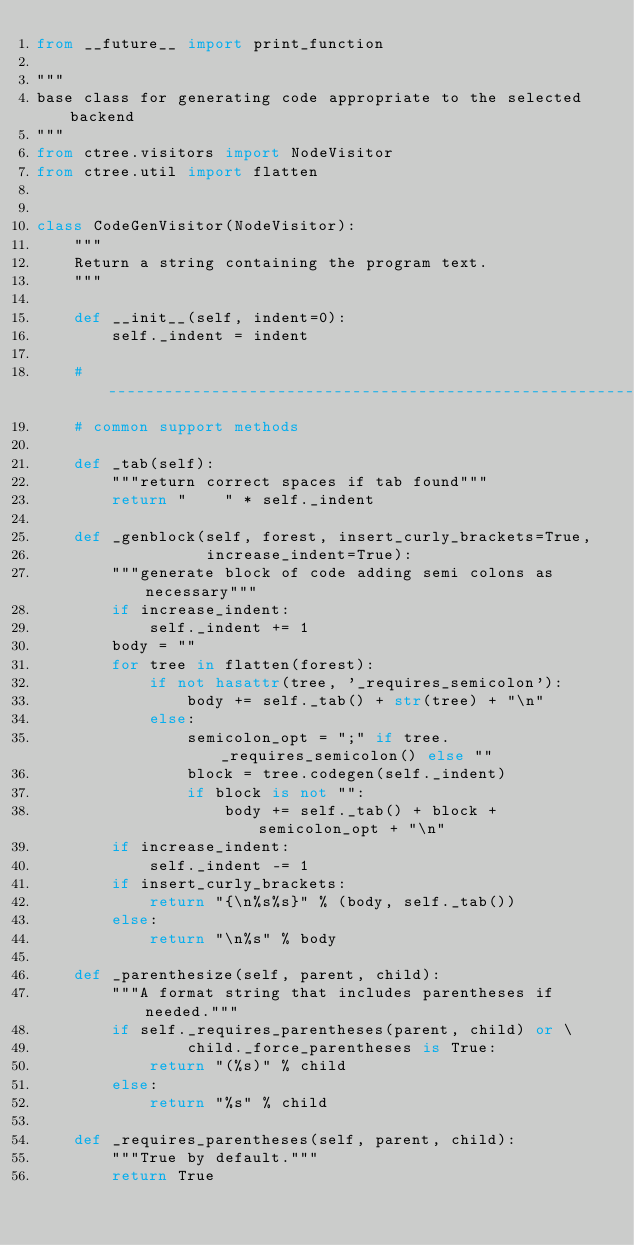<code> <loc_0><loc_0><loc_500><loc_500><_Python_>from __future__ import print_function

"""
base class for generating code appropriate to the selected backend
"""
from ctree.visitors import NodeVisitor
from ctree.util import flatten


class CodeGenVisitor(NodeVisitor):
    """
    Return a string containing the program text.
    """

    def __init__(self, indent=0):
        self._indent = indent

    # -------------------------------------------------------------------------
    # common support methods

    def _tab(self):
        """return correct spaces if tab found"""
        return "    " * self._indent

    def _genblock(self, forest, insert_curly_brackets=True,
                  increase_indent=True):
        """generate block of code adding semi colons as necessary"""
        if increase_indent:
            self._indent += 1
        body = ""
        for tree in flatten(forest):
            if not hasattr(tree, '_requires_semicolon'):
                body += self._tab() + str(tree) + "\n"
            else:
                semicolon_opt = ";" if tree._requires_semicolon() else ""
                block = tree.codegen(self._indent)
                if block is not "":
                    body += self._tab() + block + semicolon_opt + "\n"
        if increase_indent:
            self._indent -= 1
        if insert_curly_brackets:
            return "{\n%s%s}" % (body, self._tab())
        else:
            return "\n%s" % body

    def _parenthesize(self, parent, child):
        """A format string that includes parentheses if needed."""
        if self._requires_parentheses(parent, child) or \
                child._force_parentheses is True:
            return "(%s)" % child
        else:
            return "%s" % child

    def _requires_parentheses(self, parent, child):
        """True by default."""
        return True
</code> 